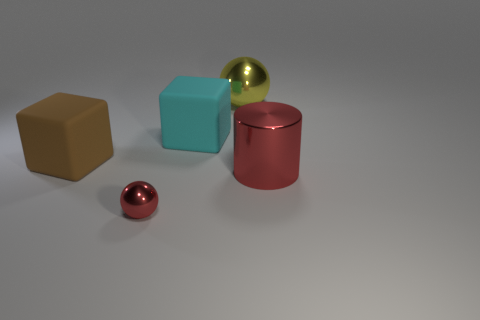Is there any other thing that is the same size as the red ball?
Provide a succinct answer. No. The red shiny object that is behind the red object in front of the big red object is what shape?
Provide a short and direct response. Cylinder. Do the cube that is right of the big brown object and the cylinder have the same material?
Give a very brief answer. No. What number of red things are tiny balls or cylinders?
Provide a short and direct response. 2. Are there any tiny shiny spheres of the same color as the big cylinder?
Your response must be concise. Yes. Are there any red balls that have the same material as the large yellow sphere?
Keep it short and to the point. Yes. There is a metallic object that is in front of the big metallic sphere and behind the small object; what shape is it?
Offer a terse response. Cylinder. How many small objects are either red cylinders or metallic objects?
Make the answer very short. 1. What is the material of the large red object?
Offer a very short reply. Metal. What number of other objects are there of the same shape as the large cyan object?
Your response must be concise. 1. 